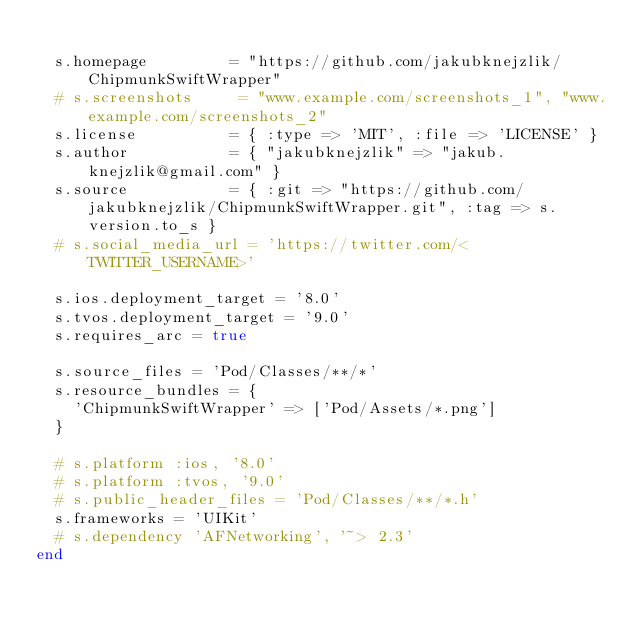<code> <loc_0><loc_0><loc_500><loc_500><_Ruby_>
  s.homepage         = "https://github.com/jakubknejzlik/ChipmunkSwiftWrapper"
  # s.screenshots     = "www.example.com/screenshots_1", "www.example.com/screenshots_2"
  s.license          = { :type => 'MIT', :file => 'LICENSE' }
  s.author           = { "jakubknejzlik" => "jakub.knejzlik@gmail.com" }
  s.source           = { :git => "https://github.com/jakubknejzlik/ChipmunkSwiftWrapper.git", :tag => s.version.to_s }
  # s.social_media_url = 'https://twitter.com/<TWITTER_USERNAME>'

  s.ios.deployment_target = '8.0'
  s.tvos.deployment_target = '9.0'
  s.requires_arc = true

  s.source_files = 'Pod/Classes/**/*'
  s.resource_bundles = {
    'ChipmunkSwiftWrapper' => ['Pod/Assets/*.png']
  }

  # s.platform :ios, '8.0'
  # s.platform :tvos, '9.0'
  # s.public_header_files = 'Pod/Classes/**/*.h'
  s.frameworks = 'UIKit'
  # s.dependency 'AFNetworking', '~> 2.3'
end
</code> 